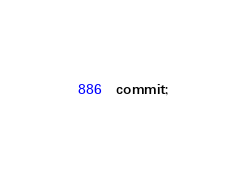Convert code to text. <code><loc_0><loc_0><loc_500><loc_500><_SQL_>commit;

</code> 